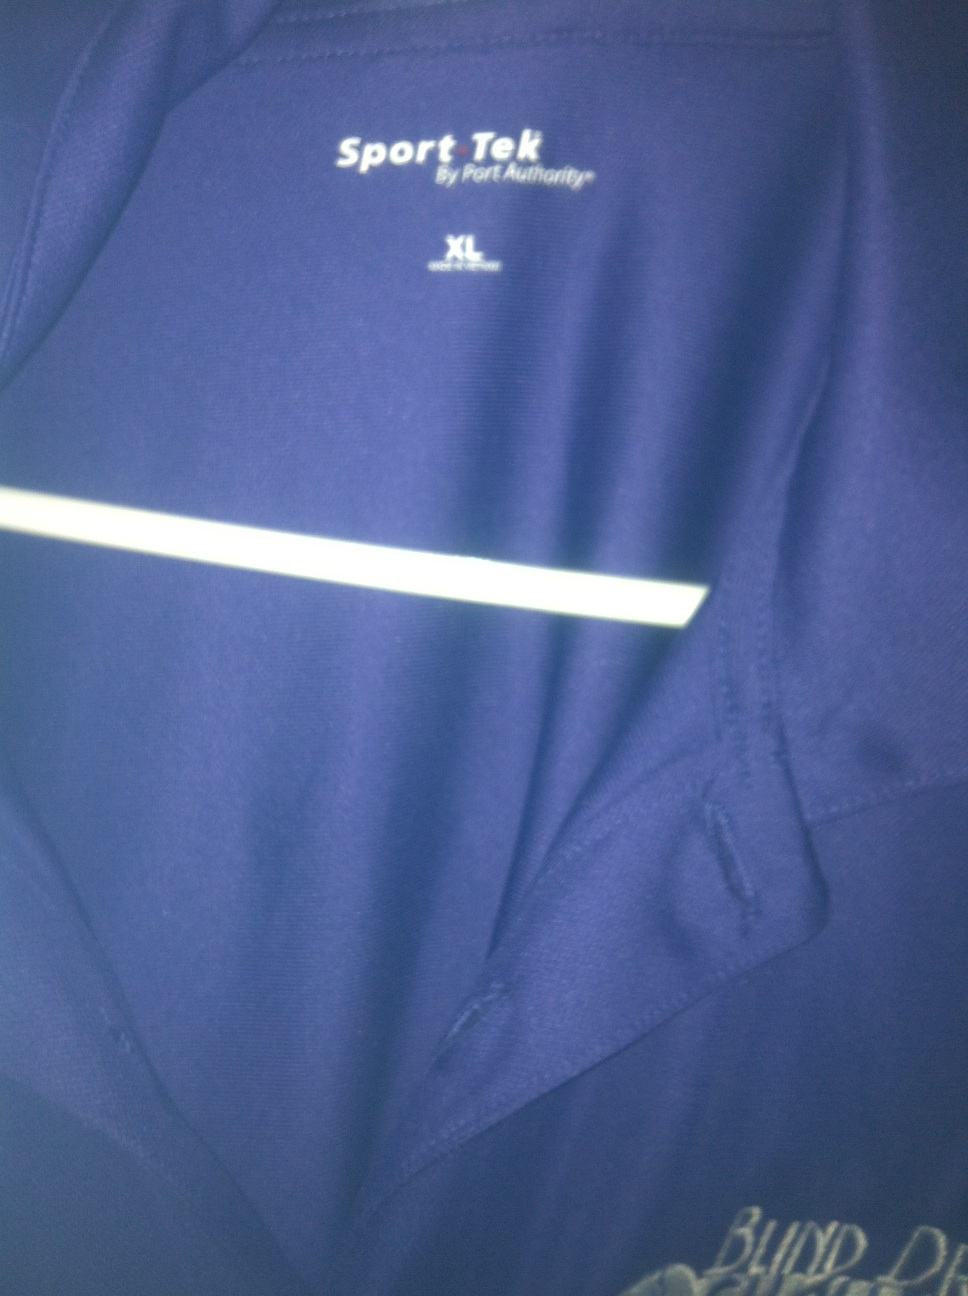Can you tell me more about the reflective feature seen on this shirt? Certainly! The reflective stripe on this shirt enhances visibility in low-light conditions, making it a practical feature for outdoor activities like running or cycling during dawn, dusk, or nighttime. It's a safety element designed to catch light and alert others to the wearer's presence. 